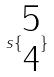<formula> <loc_0><loc_0><loc_500><loc_500>s \{ \begin{matrix} 5 \\ 4 \end{matrix} \}</formula> 